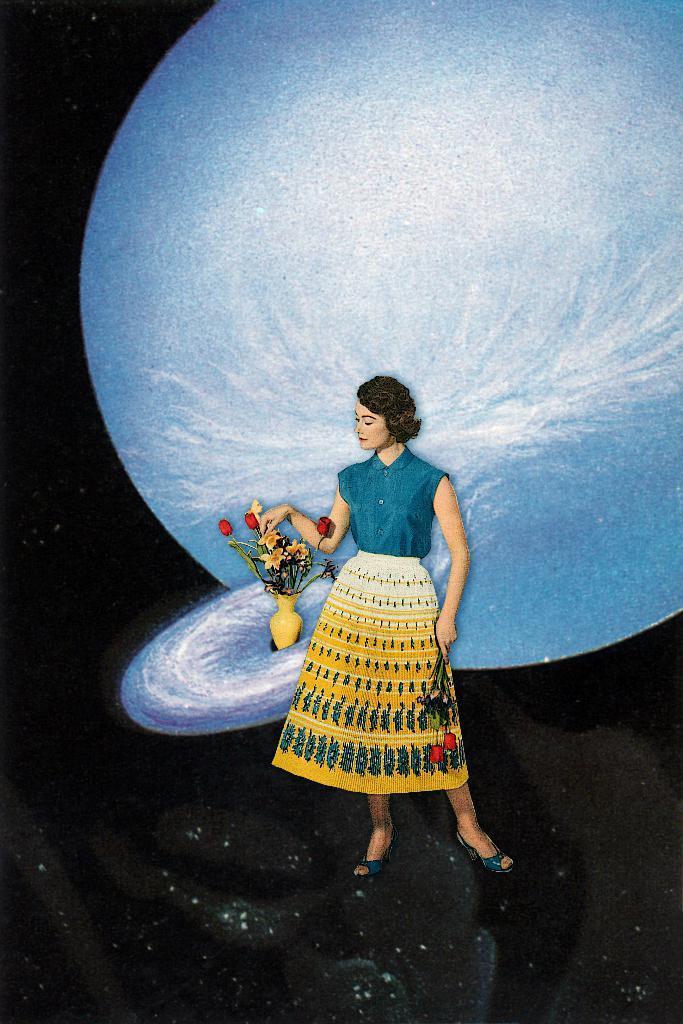Please provide a concise description of this image. This is an edited picture. In the picture there is a woman and a flower vase. In the background there are planets. The picture has dark background. 